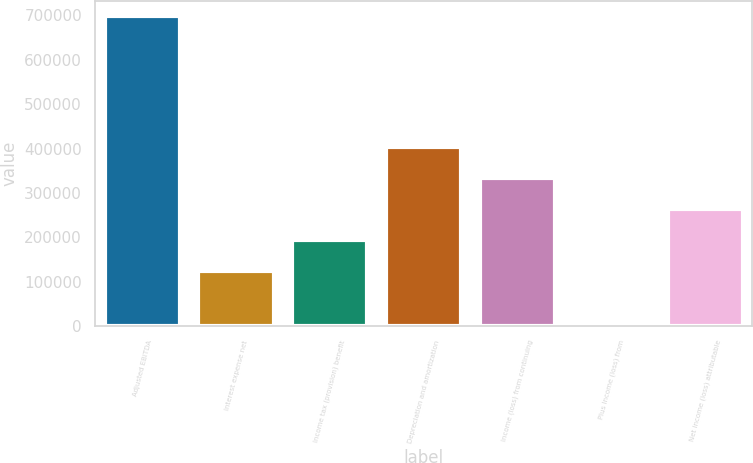<chart> <loc_0><loc_0><loc_500><loc_500><bar_chart><fcel>Adjusted EBITDA<fcel>Interest expense net<fcel>Income tax (provision) benefit<fcel>Depreciation and amortization<fcel>Income (loss) from continuing<fcel>Plus Income (loss) from<fcel>Net income (loss) attributable<nl><fcel>698108<fcel>124363<fcel>194018<fcel>402983<fcel>333328<fcel>1558<fcel>263673<nl></chart> 